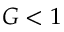Convert formula to latex. <formula><loc_0><loc_0><loc_500><loc_500>G < 1</formula> 